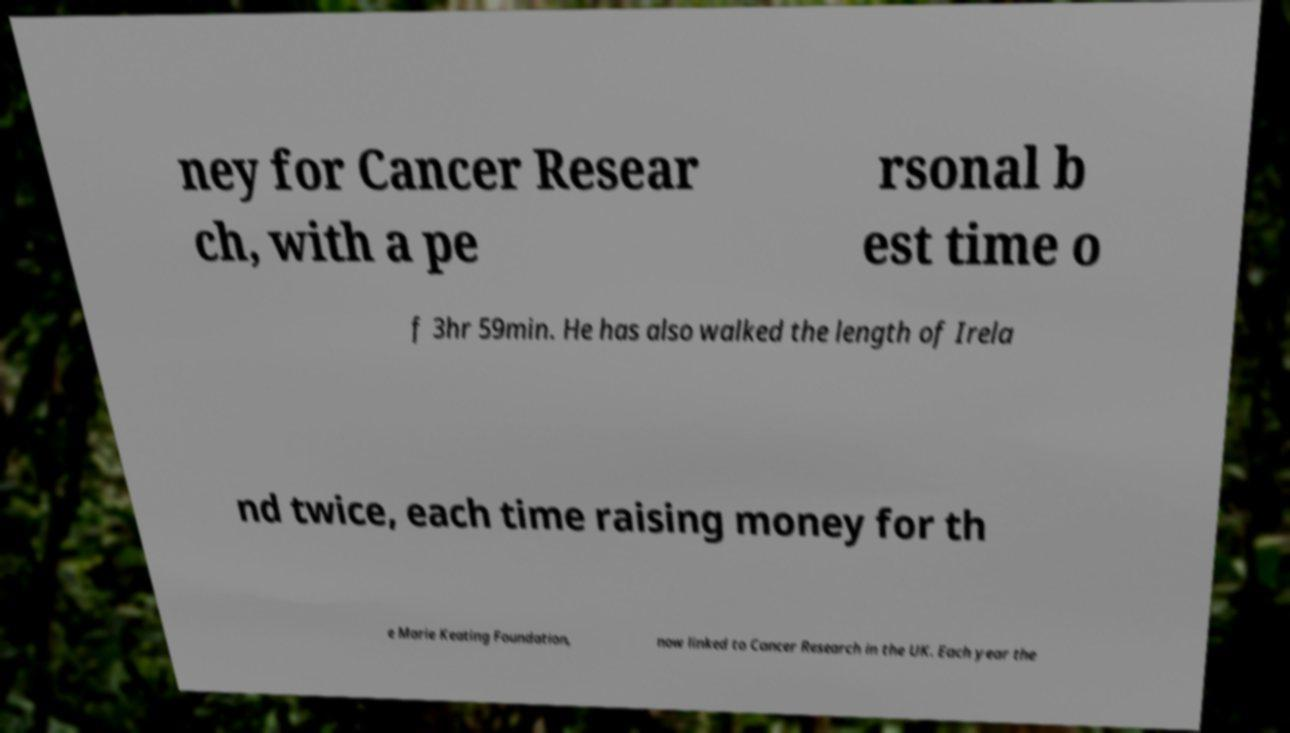There's text embedded in this image that I need extracted. Can you transcribe it verbatim? ney for Cancer Resear ch, with a pe rsonal b est time o f 3hr 59min. He has also walked the length of Irela nd twice, each time raising money for th e Marie Keating Foundation, now linked to Cancer Research in the UK. Each year the 